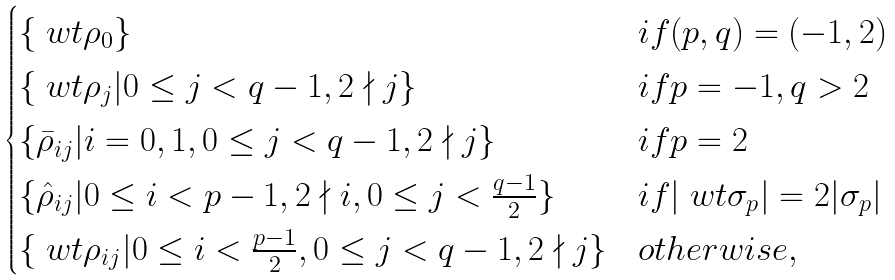Convert formula to latex. <formula><loc_0><loc_0><loc_500><loc_500>\begin{cases} \{ \ w t \rho _ { 0 } \} & i f ( p , q ) = ( - 1 , 2 ) \\ \{ \ w t \rho _ { j } | 0 \leq j < q - 1 , 2 \nmid j \} & i f p = - 1 , q > 2 \\ \{ \bar { \rho } _ { i j } | i = 0 , 1 , 0 \leq j < q - 1 , 2 \nmid j \} & i f p = 2 \\ \{ \hat { \rho } _ { i j } | 0 \leq i < p - 1 , 2 \nmid i , 0 \leq j < \frac { q - 1 } 2 \} & i f | \ w t \sigma _ { p } | = 2 | \sigma _ { p } | \\ \{ \ w t \rho _ { i j } | 0 \leq i < \frac { p - 1 } 2 , 0 \leq j < q - 1 , 2 \nmid j \} & o t h e r w i s e , \end{cases}</formula> 